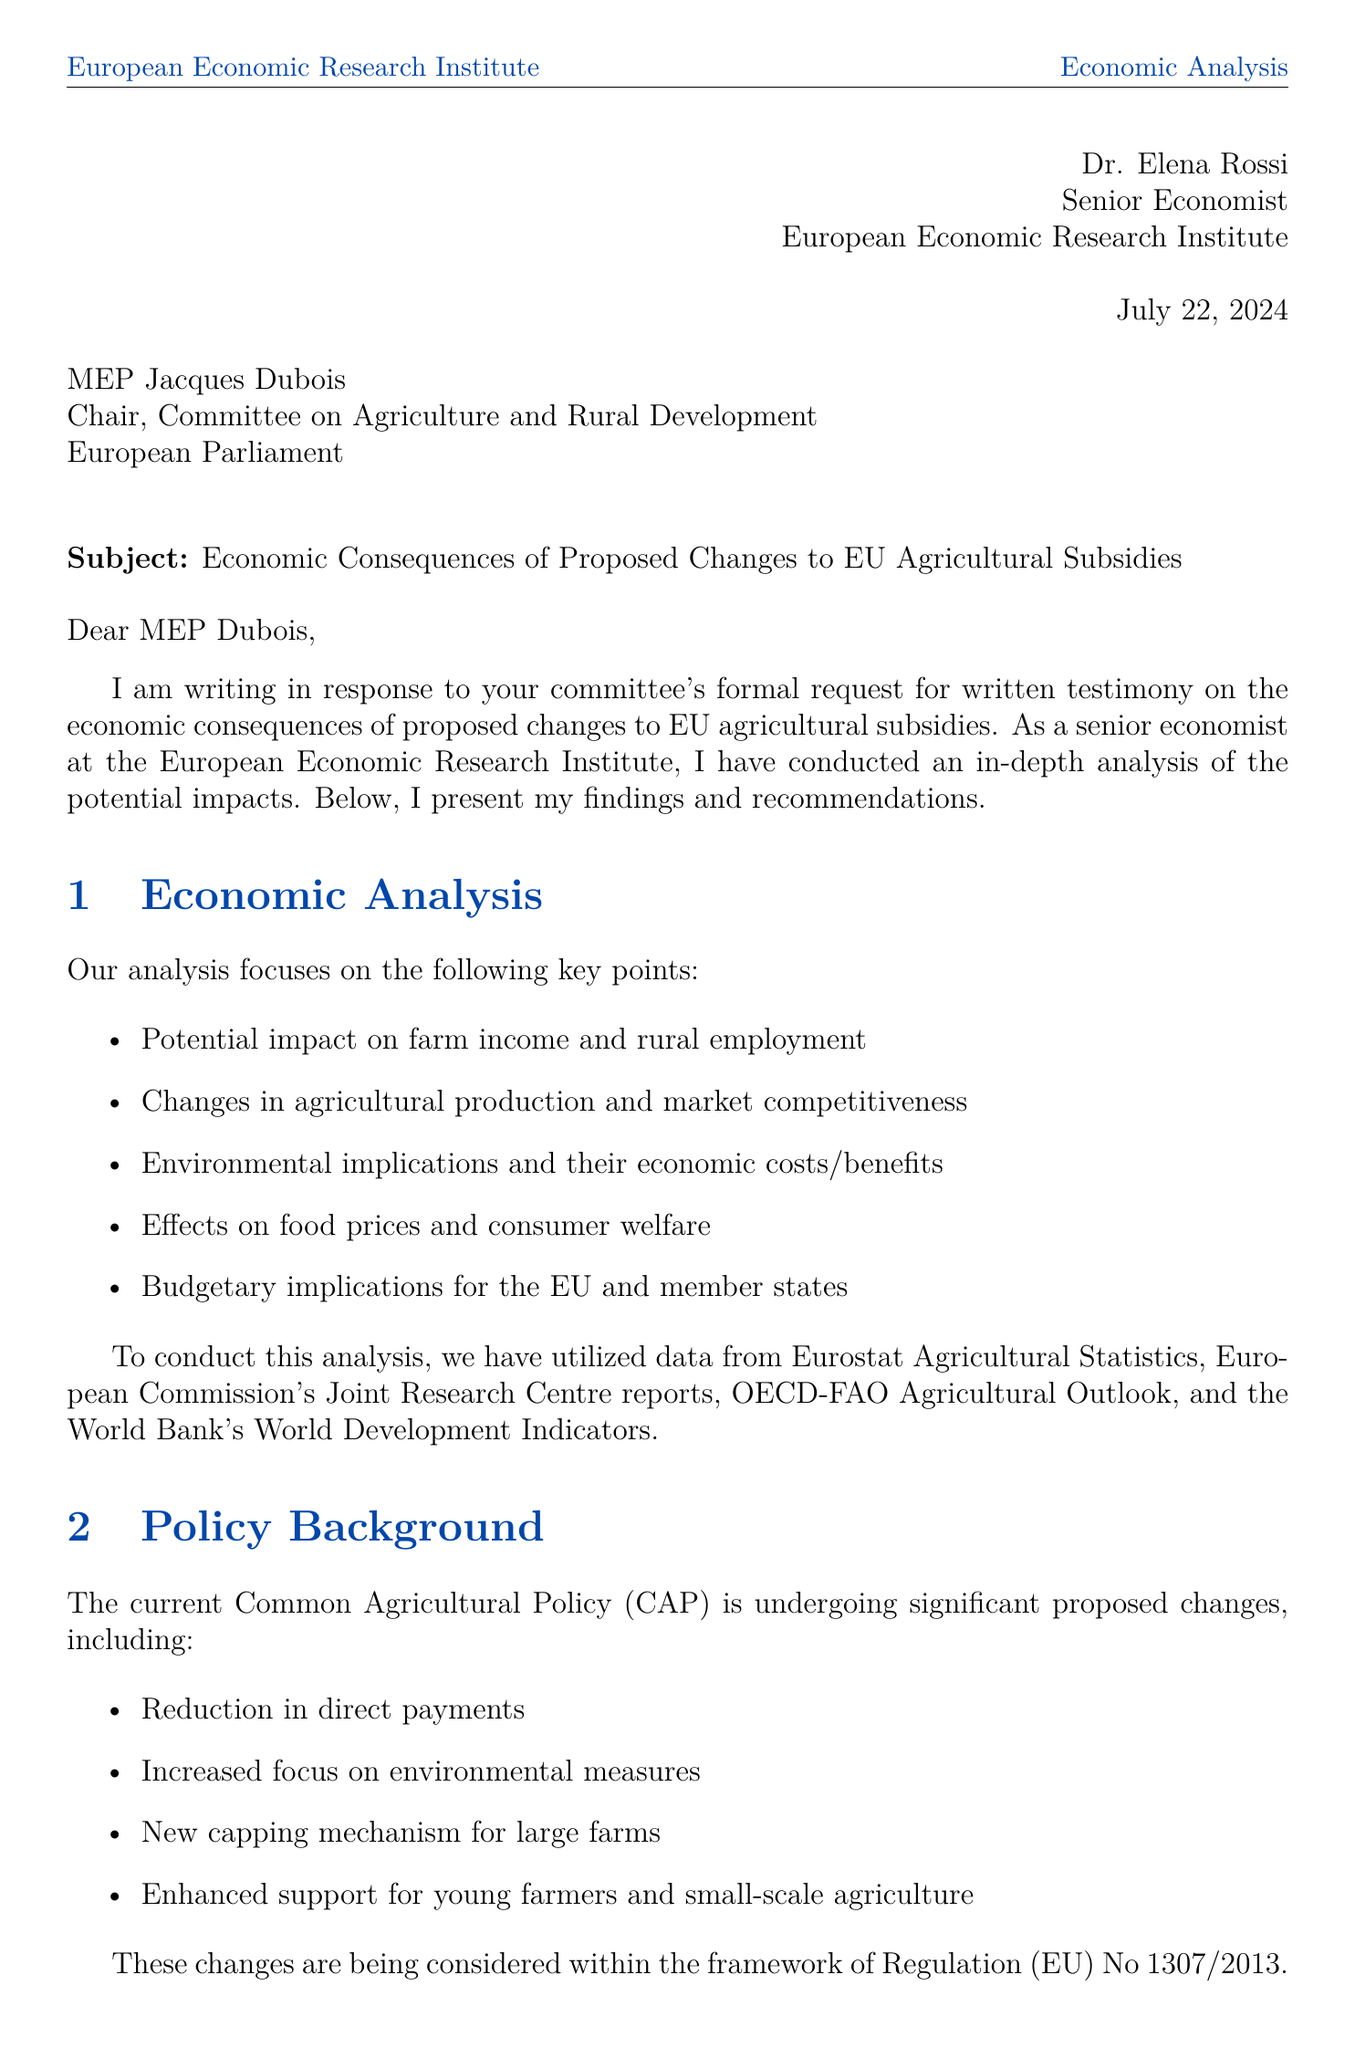what is the sender's name? The sender's name is mentioned at the beginning of the letter.
Answer: Dr. Elena Rossi who is the recipient of the letter? The recipient's name and title are specified under the recipient section of the letter.
Answer: MEP Jacques Dubois what is the subject of the letter? The subject line clearly states the main topic of the letter.
Answer: Economic Consequences of Proposed Changes to EU Agricultural Subsidies what are the proposed changes to EU agricultural subsidies? The specific changes are listed in the policy background section of the letter.
Answer: Reduction in direct payments, Increased focus on environmental measures, New capping mechanism for large farms, Enhanced support for young farmers and small-scale agriculture which economic model is mentioned in the economic analysis? The models used for analysis are explicitly outlined in the economic models section.
Answer: CAPRI (Common Agricultural Policy Regionalized Impact) model what is one recommendation provided in the letter? Recommendations are listed in their own section, indicating the suggested actions.
Answer: Phased implementation of subsidy changes what potential challenge is identified in the document? Challenges are enumerated in the document, highlighting possible issues with the proposed changes.
Answer: Resistance from certain member states and farming lobbies which organization's reports were used as data sources? The letter lists specific data sources used for the analysis.
Answer: European Commission's Joint Research Centre reports how many regions are compared in the comparative analysis? The document states the regions that are the focus of the comparative analysis.
Answer: Three what is the current policy being discussed? The current policy relevant to the proposed changes is referenced at the beginning of the policy background section.
Answer: Common Agricultural Policy (CAP) 